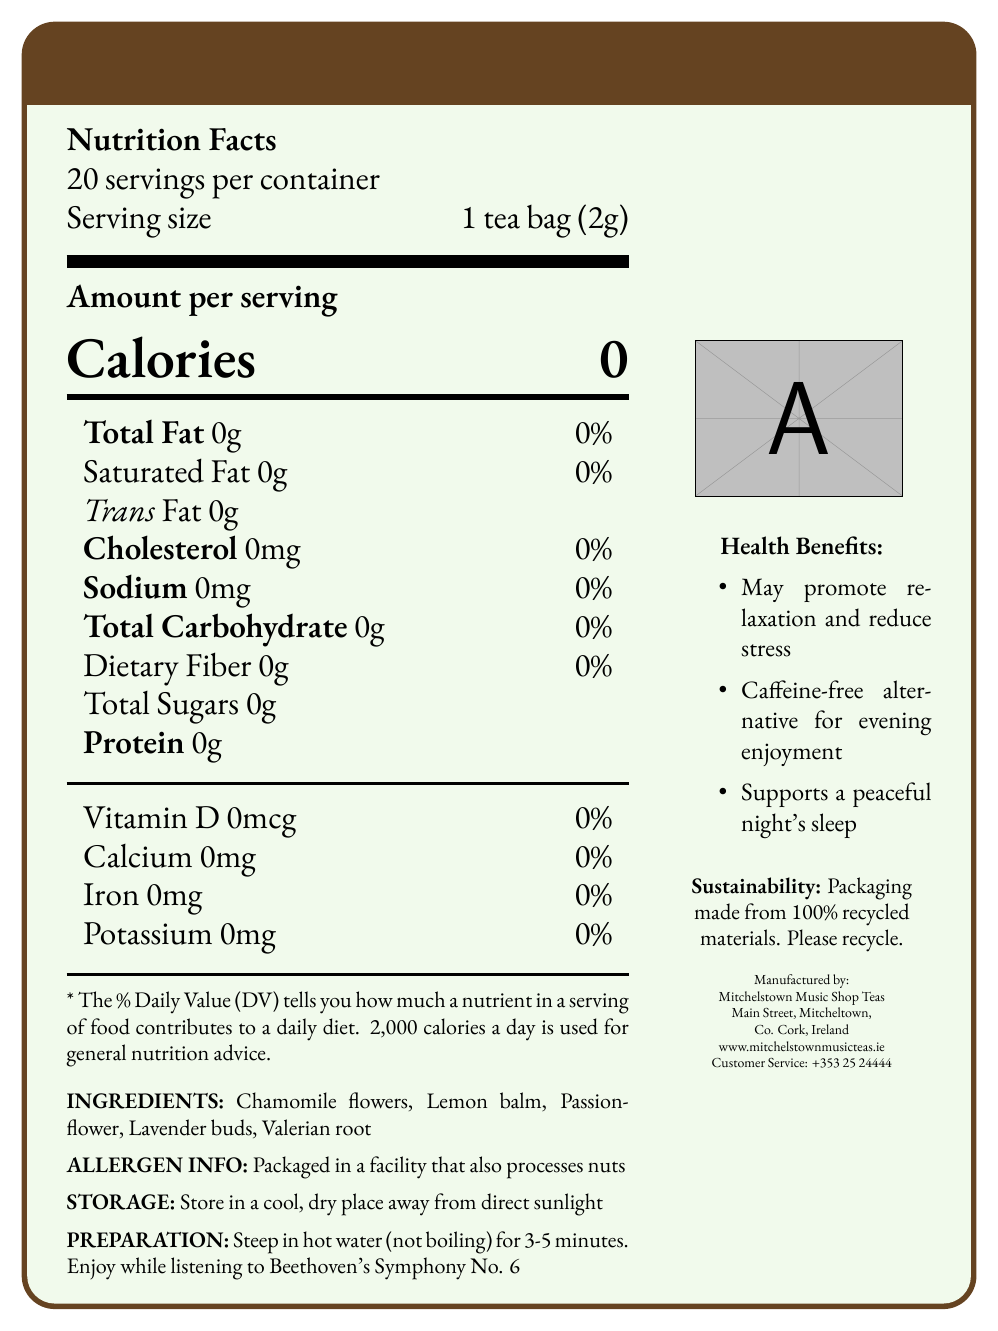Who manufactures Symphony Serenade Herbal Tea? The document states that the manufacturer is Mitchelstown Music Shop Teas.
Answer: Mitchelstown Music Shop Teas What are the main ingredients of Symphony Serenade Herbal Tea? The ingredients listed include Chamomile flowers, Lemon balm, Passionflower, Lavender buds, and Valerian root.
Answer: Chamomile flowers, Lemon balm, Passionflower, Lavender buds, Valerian root How many servings are in one container of Symphony Serenade Herbal Tea? The document specifies that there are 20 servings per container.
Answer: 20 servings How many calories are in a serving of Symphony Serenade Herbal Tea? The document clearly mentions that each serving has 0 calories.
Answer: 0 calories Where should Symphony Serenade Herbal Tea be stored? The storage instructions state to store the tea in a cool, dry place away from direct sunlight.
Answer: In a cool, dry place away from direct sunlight Which of the following is NOT an ingredient in Symphony Serenade Herbal Tea? A. Chamomile flowers B. Lemon balm C. Ginger D. Lavender buds The ingredients listed do not include ginger. They are Chamomile flowers, Lemon balm, Passionflower, Lavender buds, and Valerian root.
Answer: C. Ginger What is the recommended preparation method for Symphony Serenade Herbal Tea? A. Steep in boiling water for 5 minutes B. Steep in hot water (not boiling) for 3-5 minutes C. Microwave for 2 minutes D. Steep in cold water for 10 minutes The recommended preparation instructions are to steep in hot water (not boiling) for 3-5 minutes.
Answer: B. Steep in hot water (not boiling) for 3-5 minutes Is Symphony Serenade Herbal Tea caffeine-free? The document states that Symphony Serenade Herbal Tea is a caffeine-free alternative for evening enjoyment.
Answer: Yes What health benefits does Symphony Serenade Herbal Tea provide? The health benefits listed include promoting relaxation and reducing stress, and supporting a peaceful night's sleep.
Answer: May promote relaxation and reduce stress, supports a peaceful night's sleep Is there information about the exact amount of each ingredient in Symphony Serenade Herbal Tea? The document lists the ingredients but does not specify the exact amounts of each.
Answer: Not enough information Summarize the main idea of the document. The document describes the product Symphony Serenade Herbal Tea, highlighting its zero-calorie content, calming ingredients, allergen info, storage and preparation instructions, health benefits, and its sustainable packaging. It is manufactured by Mitchelstown Music Shop Teas, and the recommended way to enjoy it is while listening to Beethoven's Symphony No. 6.
Answer: The document provides detailed information about Symphony Serenade Herbal Tea, including its nutritional facts, ingredients, storage and preparation instructions, health benefits, sustainability information, and manufacturer details. 